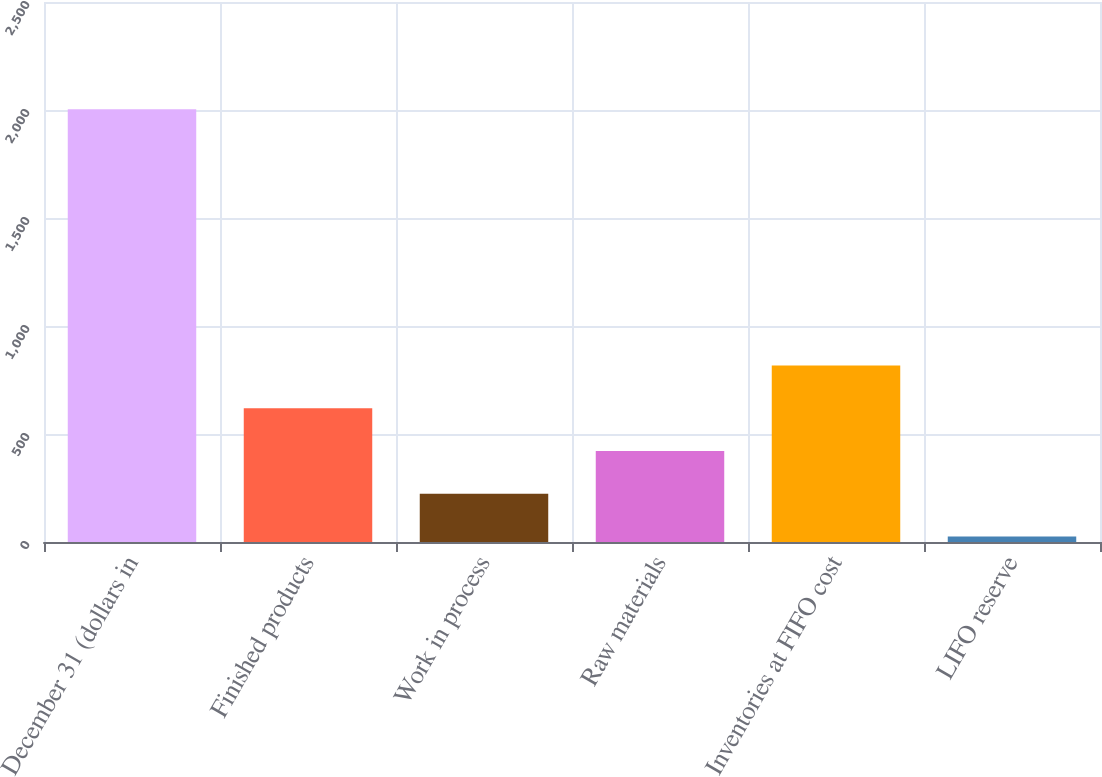<chart> <loc_0><loc_0><loc_500><loc_500><bar_chart><fcel>December 31 (dollars in<fcel>Finished products<fcel>Work in process<fcel>Raw materials<fcel>Inventories at FIFO cost<fcel>LIFO reserve<nl><fcel>2003<fcel>618.96<fcel>223.52<fcel>421.24<fcel>816.68<fcel>25.8<nl></chart> 